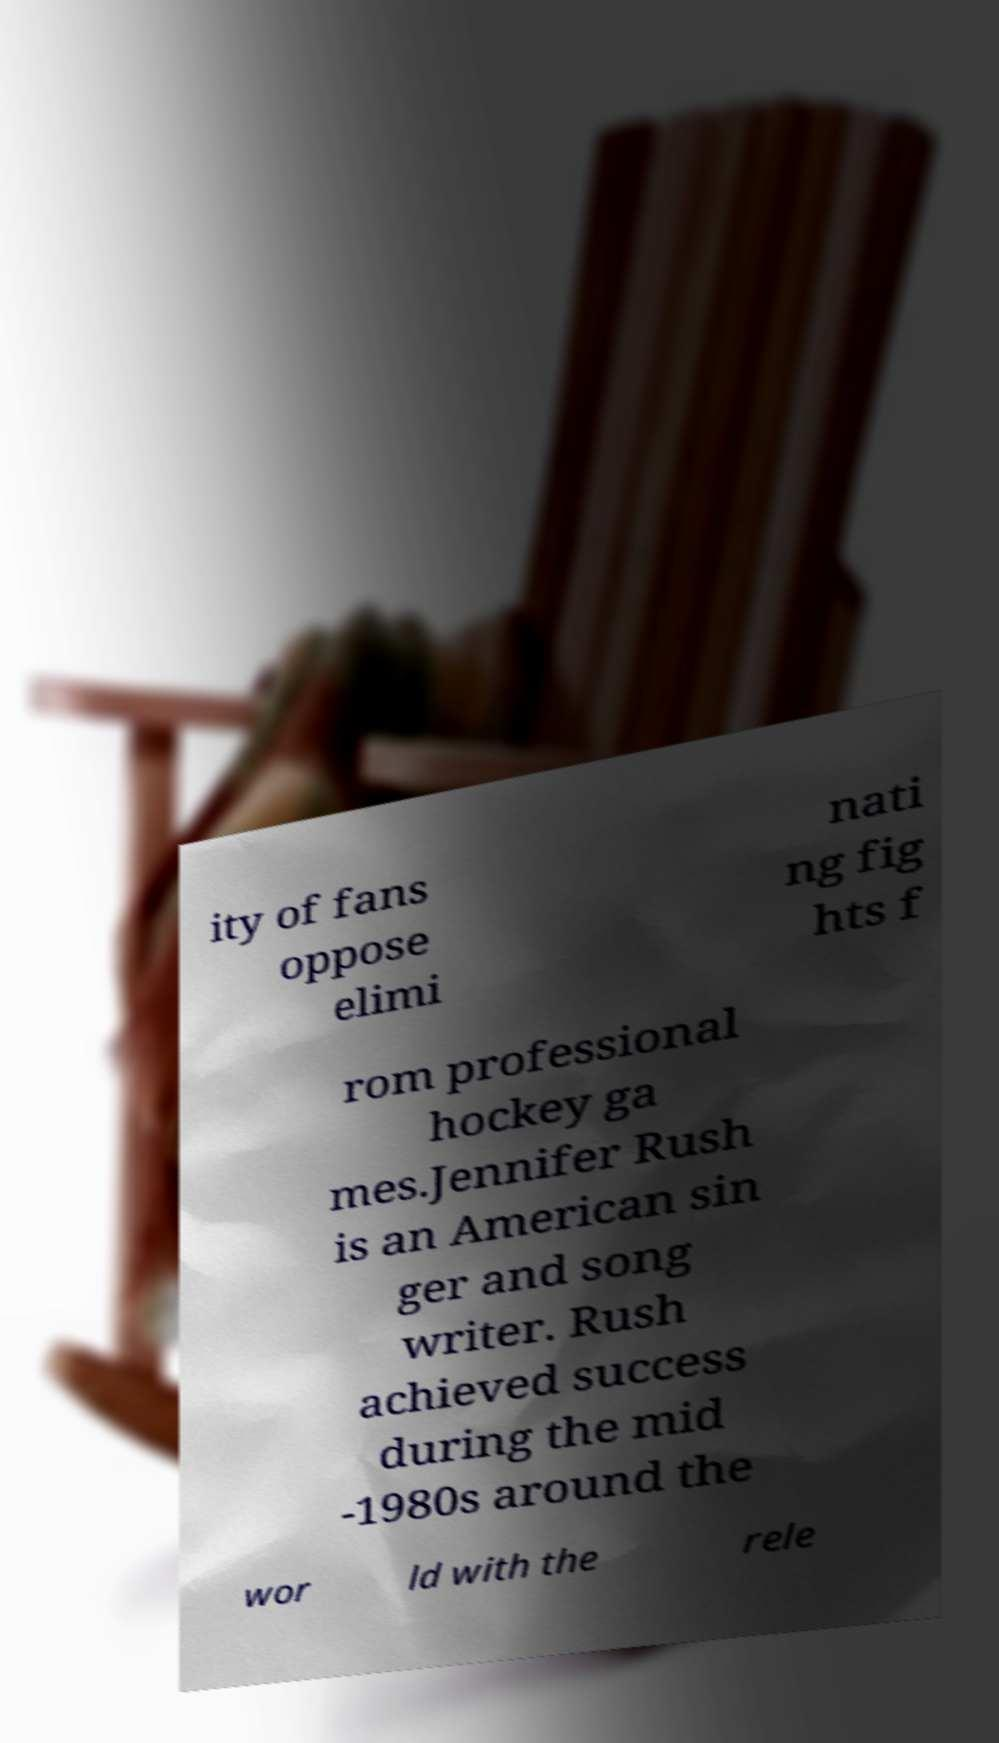Please read and relay the text visible in this image. What does it say? ity of fans oppose elimi nati ng fig hts f rom professional hockey ga mes.Jennifer Rush is an American sin ger and song writer. Rush achieved success during the mid -1980s around the wor ld with the rele 